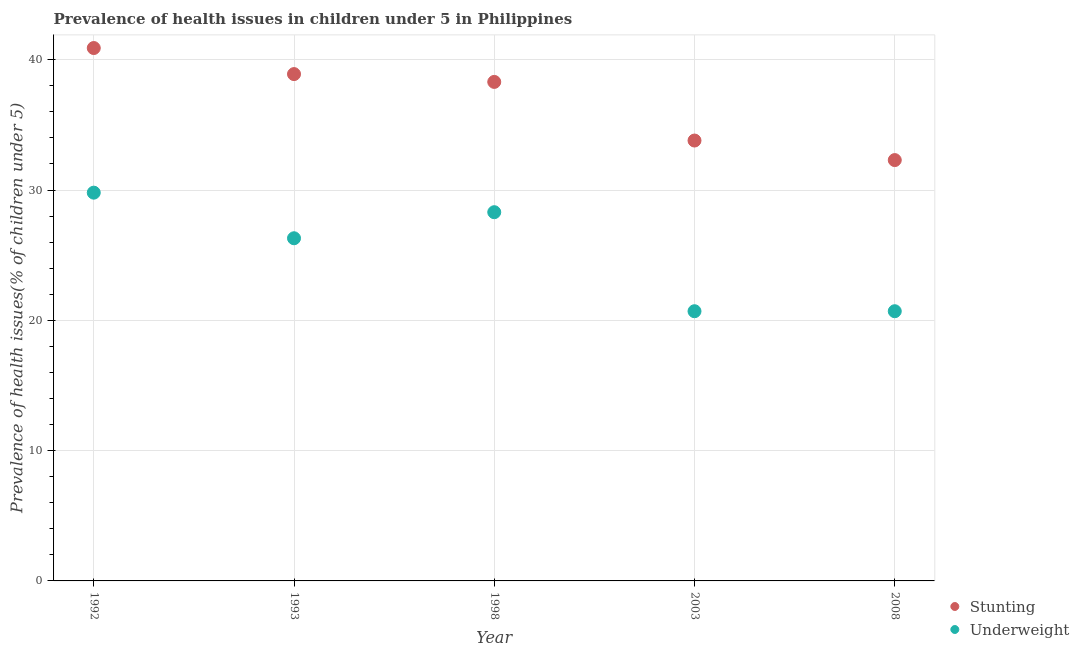Is the number of dotlines equal to the number of legend labels?
Your answer should be very brief. Yes. What is the percentage of underweight children in 1998?
Make the answer very short. 28.3. Across all years, what is the maximum percentage of stunted children?
Offer a very short reply. 40.9. Across all years, what is the minimum percentage of stunted children?
Your answer should be very brief. 32.3. What is the total percentage of underweight children in the graph?
Your response must be concise. 125.8. What is the difference between the percentage of underweight children in 1998 and that in 2008?
Your response must be concise. 7.6. What is the difference between the percentage of stunted children in 1992 and the percentage of underweight children in 2008?
Provide a short and direct response. 20.2. What is the average percentage of stunted children per year?
Keep it short and to the point. 36.84. In the year 1992, what is the difference between the percentage of stunted children and percentage of underweight children?
Your response must be concise. 11.1. In how many years, is the percentage of stunted children greater than 18 %?
Your response must be concise. 5. What is the ratio of the percentage of underweight children in 1992 to that in 1998?
Your answer should be very brief. 1.05. Is the percentage of stunted children in 1993 less than that in 1998?
Your answer should be very brief. No. What is the difference between the highest and the second highest percentage of underweight children?
Provide a short and direct response. 1.5. What is the difference between the highest and the lowest percentage of underweight children?
Give a very brief answer. 9.1. In how many years, is the percentage of stunted children greater than the average percentage of stunted children taken over all years?
Your answer should be very brief. 3. Does the percentage of stunted children monotonically increase over the years?
Provide a succinct answer. No. Is the percentage of underweight children strictly greater than the percentage of stunted children over the years?
Your response must be concise. No. Is the percentage of stunted children strictly less than the percentage of underweight children over the years?
Provide a succinct answer. No. How many dotlines are there?
Provide a succinct answer. 2. How many years are there in the graph?
Your response must be concise. 5. How are the legend labels stacked?
Ensure brevity in your answer.  Vertical. What is the title of the graph?
Make the answer very short. Prevalence of health issues in children under 5 in Philippines. What is the label or title of the Y-axis?
Offer a very short reply. Prevalence of health issues(% of children under 5). What is the Prevalence of health issues(% of children under 5) of Stunting in 1992?
Your response must be concise. 40.9. What is the Prevalence of health issues(% of children under 5) in Underweight in 1992?
Make the answer very short. 29.8. What is the Prevalence of health issues(% of children under 5) in Stunting in 1993?
Offer a very short reply. 38.9. What is the Prevalence of health issues(% of children under 5) of Underweight in 1993?
Offer a very short reply. 26.3. What is the Prevalence of health issues(% of children under 5) of Stunting in 1998?
Your response must be concise. 38.3. What is the Prevalence of health issues(% of children under 5) of Underweight in 1998?
Offer a terse response. 28.3. What is the Prevalence of health issues(% of children under 5) in Stunting in 2003?
Your answer should be compact. 33.8. What is the Prevalence of health issues(% of children under 5) of Underweight in 2003?
Provide a short and direct response. 20.7. What is the Prevalence of health issues(% of children under 5) in Stunting in 2008?
Offer a very short reply. 32.3. What is the Prevalence of health issues(% of children under 5) of Underweight in 2008?
Keep it short and to the point. 20.7. Across all years, what is the maximum Prevalence of health issues(% of children under 5) of Stunting?
Your response must be concise. 40.9. Across all years, what is the maximum Prevalence of health issues(% of children under 5) of Underweight?
Offer a very short reply. 29.8. Across all years, what is the minimum Prevalence of health issues(% of children under 5) in Stunting?
Offer a terse response. 32.3. Across all years, what is the minimum Prevalence of health issues(% of children under 5) of Underweight?
Provide a short and direct response. 20.7. What is the total Prevalence of health issues(% of children under 5) of Stunting in the graph?
Provide a succinct answer. 184.2. What is the total Prevalence of health issues(% of children under 5) of Underweight in the graph?
Offer a very short reply. 125.8. What is the difference between the Prevalence of health issues(% of children under 5) in Underweight in 1992 and that in 1993?
Your answer should be compact. 3.5. What is the difference between the Prevalence of health issues(% of children under 5) of Stunting in 1992 and that in 1998?
Give a very brief answer. 2.6. What is the difference between the Prevalence of health issues(% of children under 5) of Underweight in 1992 and that in 2003?
Your answer should be very brief. 9.1. What is the difference between the Prevalence of health issues(% of children under 5) of Stunting in 1992 and that in 2008?
Give a very brief answer. 8.6. What is the difference between the Prevalence of health issues(% of children under 5) of Stunting in 1993 and that in 1998?
Provide a short and direct response. 0.6. What is the difference between the Prevalence of health issues(% of children under 5) of Underweight in 1993 and that in 2008?
Keep it short and to the point. 5.6. What is the difference between the Prevalence of health issues(% of children under 5) of Stunting in 1998 and that in 2003?
Provide a succinct answer. 4.5. What is the difference between the Prevalence of health issues(% of children under 5) of Underweight in 1998 and that in 2003?
Keep it short and to the point. 7.6. What is the difference between the Prevalence of health issues(% of children under 5) in Stunting in 2003 and that in 2008?
Your answer should be very brief. 1.5. What is the difference between the Prevalence of health issues(% of children under 5) in Underweight in 2003 and that in 2008?
Your answer should be very brief. 0. What is the difference between the Prevalence of health issues(% of children under 5) in Stunting in 1992 and the Prevalence of health issues(% of children under 5) in Underweight in 1993?
Offer a terse response. 14.6. What is the difference between the Prevalence of health issues(% of children under 5) of Stunting in 1992 and the Prevalence of health issues(% of children under 5) of Underweight in 1998?
Provide a short and direct response. 12.6. What is the difference between the Prevalence of health issues(% of children under 5) in Stunting in 1992 and the Prevalence of health issues(% of children under 5) in Underweight in 2003?
Provide a succinct answer. 20.2. What is the difference between the Prevalence of health issues(% of children under 5) of Stunting in 1992 and the Prevalence of health issues(% of children under 5) of Underweight in 2008?
Provide a succinct answer. 20.2. What is the difference between the Prevalence of health issues(% of children under 5) in Stunting in 1993 and the Prevalence of health issues(% of children under 5) in Underweight in 1998?
Offer a terse response. 10.6. What is the difference between the Prevalence of health issues(% of children under 5) in Stunting in 1998 and the Prevalence of health issues(% of children under 5) in Underweight in 2003?
Offer a very short reply. 17.6. What is the difference between the Prevalence of health issues(% of children under 5) of Stunting in 2003 and the Prevalence of health issues(% of children under 5) of Underweight in 2008?
Make the answer very short. 13.1. What is the average Prevalence of health issues(% of children under 5) in Stunting per year?
Provide a short and direct response. 36.84. What is the average Prevalence of health issues(% of children under 5) in Underweight per year?
Provide a short and direct response. 25.16. In the year 1993, what is the difference between the Prevalence of health issues(% of children under 5) in Stunting and Prevalence of health issues(% of children under 5) in Underweight?
Provide a short and direct response. 12.6. In the year 1998, what is the difference between the Prevalence of health issues(% of children under 5) in Stunting and Prevalence of health issues(% of children under 5) in Underweight?
Offer a terse response. 10. In the year 2003, what is the difference between the Prevalence of health issues(% of children under 5) in Stunting and Prevalence of health issues(% of children under 5) in Underweight?
Your answer should be compact. 13.1. What is the ratio of the Prevalence of health issues(% of children under 5) of Stunting in 1992 to that in 1993?
Offer a terse response. 1.05. What is the ratio of the Prevalence of health issues(% of children under 5) in Underweight in 1992 to that in 1993?
Offer a terse response. 1.13. What is the ratio of the Prevalence of health issues(% of children under 5) in Stunting in 1992 to that in 1998?
Provide a succinct answer. 1.07. What is the ratio of the Prevalence of health issues(% of children under 5) in Underweight in 1992 to that in 1998?
Ensure brevity in your answer.  1.05. What is the ratio of the Prevalence of health issues(% of children under 5) of Stunting in 1992 to that in 2003?
Your answer should be compact. 1.21. What is the ratio of the Prevalence of health issues(% of children under 5) in Underweight in 1992 to that in 2003?
Your response must be concise. 1.44. What is the ratio of the Prevalence of health issues(% of children under 5) of Stunting in 1992 to that in 2008?
Offer a terse response. 1.27. What is the ratio of the Prevalence of health issues(% of children under 5) in Underweight in 1992 to that in 2008?
Your answer should be compact. 1.44. What is the ratio of the Prevalence of health issues(% of children under 5) in Stunting in 1993 to that in 1998?
Provide a short and direct response. 1.02. What is the ratio of the Prevalence of health issues(% of children under 5) of Underweight in 1993 to that in 1998?
Offer a terse response. 0.93. What is the ratio of the Prevalence of health issues(% of children under 5) of Stunting in 1993 to that in 2003?
Ensure brevity in your answer.  1.15. What is the ratio of the Prevalence of health issues(% of children under 5) in Underweight in 1993 to that in 2003?
Keep it short and to the point. 1.27. What is the ratio of the Prevalence of health issues(% of children under 5) of Stunting in 1993 to that in 2008?
Make the answer very short. 1.2. What is the ratio of the Prevalence of health issues(% of children under 5) in Underweight in 1993 to that in 2008?
Offer a terse response. 1.27. What is the ratio of the Prevalence of health issues(% of children under 5) of Stunting in 1998 to that in 2003?
Your answer should be compact. 1.13. What is the ratio of the Prevalence of health issues(% of children under 5) of Underweight in 1998 to that in 2003?
Your response must be concise. 1.37. What is the ratio of the Prevalence of health issues(% of children under 5) of Stunting in 1998 to that in 2008?
Offer a very short reply. 1.19. What is the ratio of the Prevalence of health issues(% of children under 5) of Underweight in 1998 to that in 2008?
Ensure brevity in your answer.  1.37. What is the ratio of the Prevalence of health issues(% of children under 5) of Stunting in 2003 to that in 2008?
Make the answer very short. 1.05. What is the difference between the highest and the second highest Prevalence of health issues(% of children under 5) of Stunting?
Provide a short and direct response. 2. What is the difference between the highest and the lowest Prevalence of health issues(% of children under 5) of Stunting?
Provide a succinct answer. 8.6. 